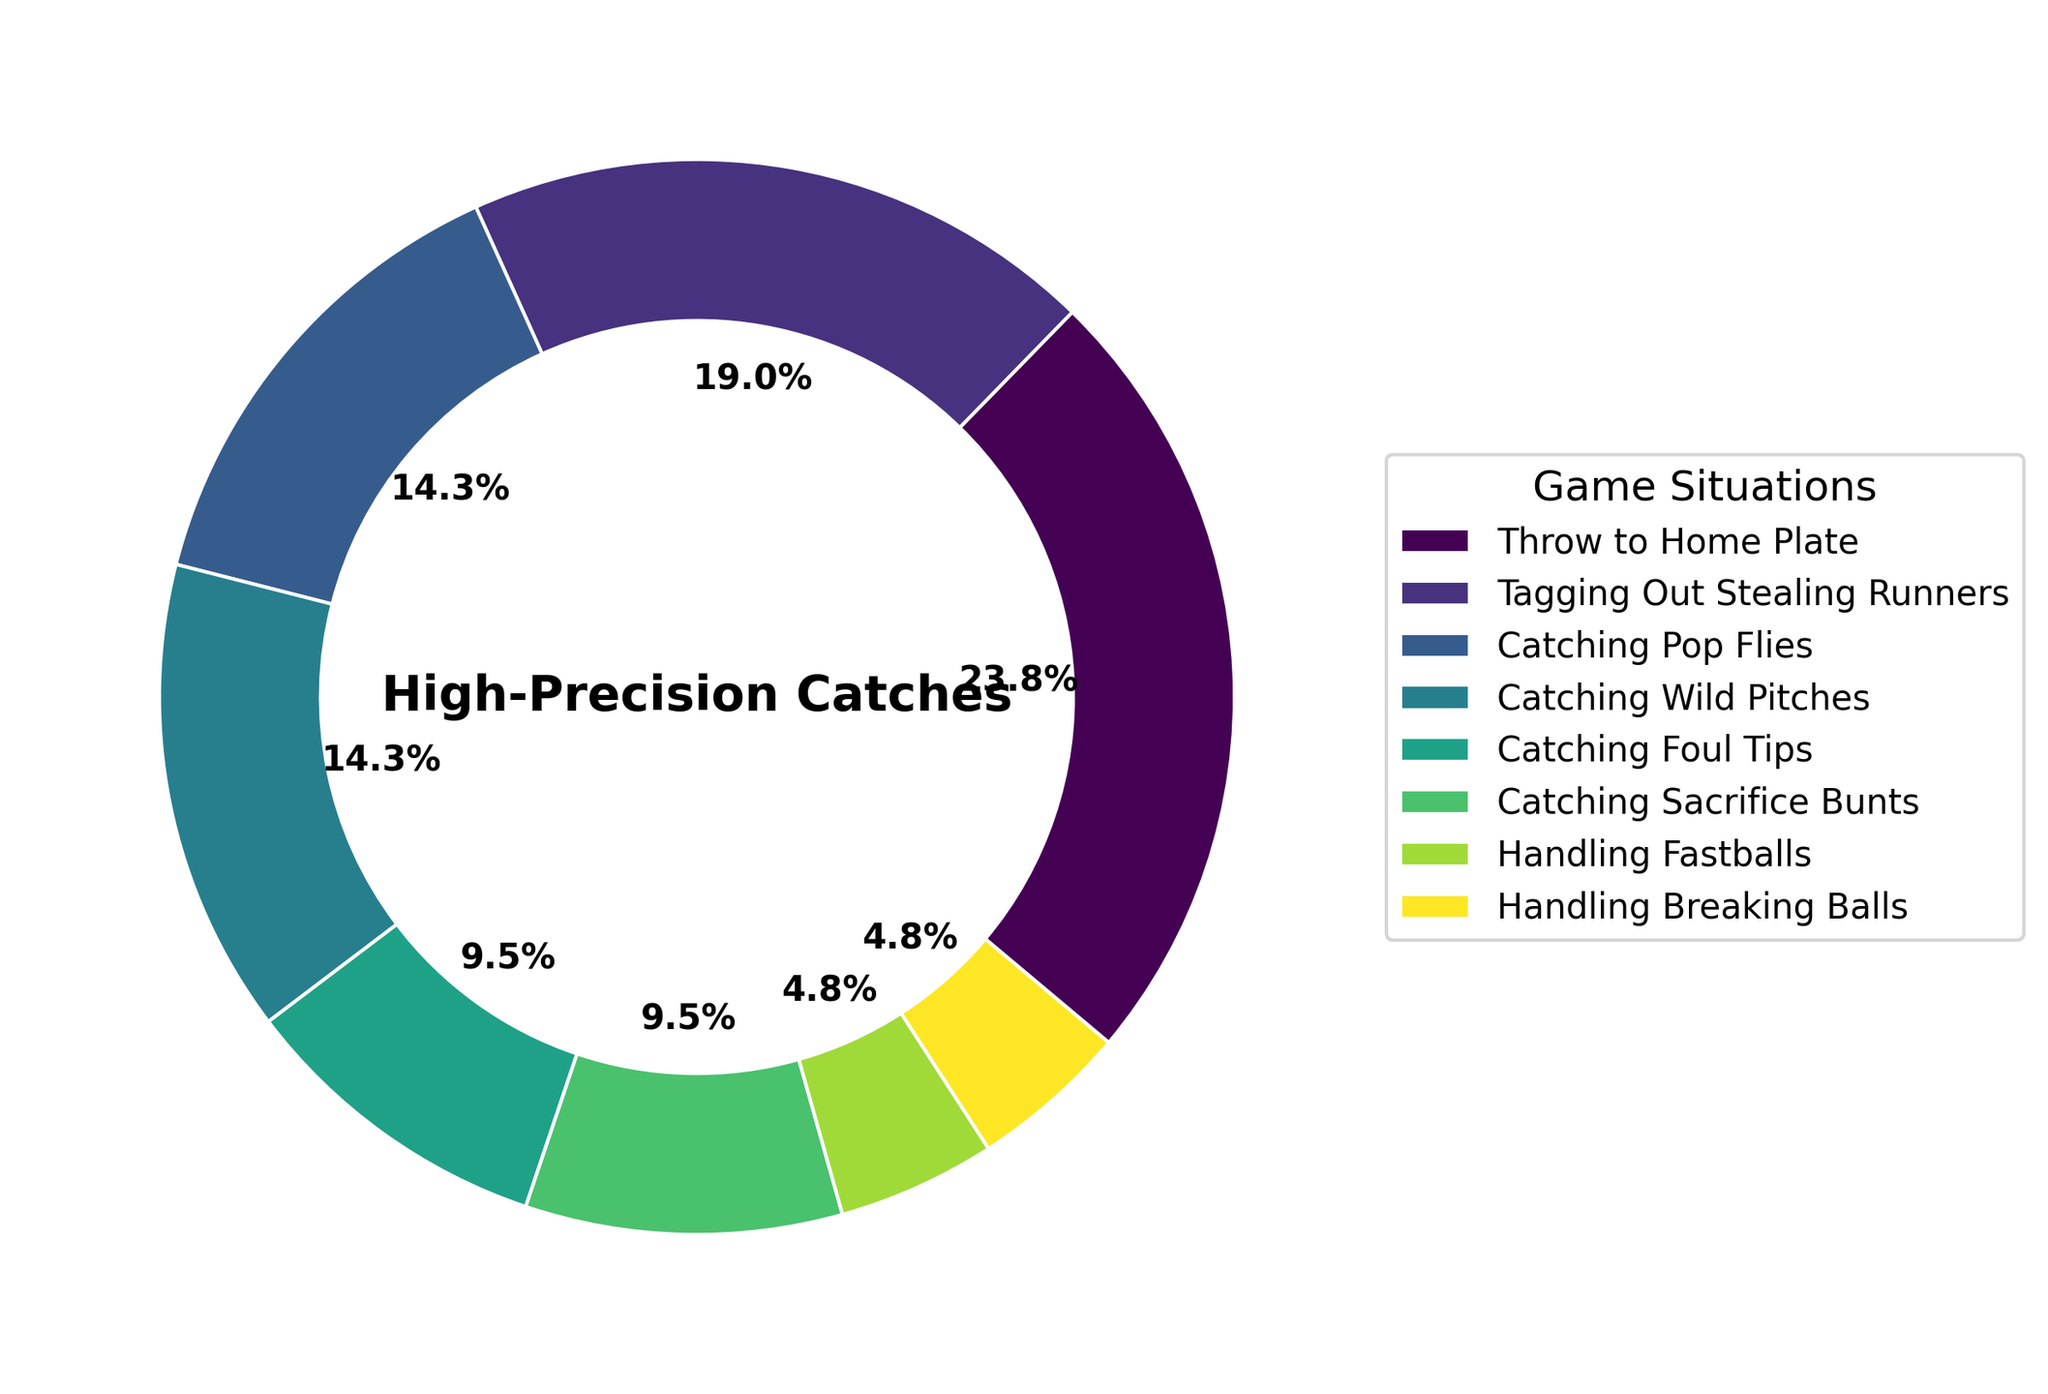What's the game situation with the highest percentage? The largest wedge in the ring chart corresponds to "Throw to Home Plate" with 25%. This segment is visually larger than the others.
Answer: Throw to Home Plate Which game situation has a larger percentage: Tagging Out Stealing Runners or Catching Wild Pitches? Comparing the two wedges in the chart, "Tagging Out Stealing Runners" is larger with 20%, whereas "Catching Wild Pitches" represents 15%.
Answer: Tagging Out Stealing Runners What is the combined percentage of Handling Fastballs and Handling Breaking Balls? The percentage for Handling Fastballs is 5% and for Handling Breaking Balls is 5%. Summing these values gives 5% + 5% = 10%.
Answer: 10% How much larger is the percentage of Catching Pop Flies compared to Catching Foul Tips? Catching Pop Flies has a percentage of 15% while Catching Foul Tips has 10%. The difference is 15% - 10% = 5%.
Answer: 5% Which game situations together account for exactly half of all high-precision catches? Total percentage: Throw to Home Plate (25%) + Tagging Out Stealing Runners (20%) + Handling Fastballs (5%) = 25% + 20% + 5% = 50%. These three game situations together make up half of the total.
Answer: Throw to Home Plate, Tagging Out Stealing Runners, Handling Fastballs Rank the game situations from highest to lowest percentage. Observing the wedges' sizes and percentages: Throw to Home Plate (25%), Tagging Out Stealing Runners (20%), Catching Pop Flies (15%), Catching Wild Pitches (15%), Catching Foul Tips (10%), Catching Sacrifice Bunts (10%), Handling Fastballs (5%), and Handling Breaking Balls (5%).
Answer: 1. Throw to Home Plate, 2. Tagging Out Stealing Runners, 3. Catching Pop Flies, 3. Catching Wild Pitches, 5. Catching Foul Tips, 5. Catching Sacrifice Bunts, 7. Handling Fastballs, 7. Handling Breaking Balls Which color represents the game situation of Catching Sacrifice Bunts? Each wedge in the ring chart has a distinct color. Looking at the legend, the specific color associated with "Catching Sacrifice Bunts" segment needs to be identified visually from the chart and its legend.
Answer: Color as shown in the chart and legend 